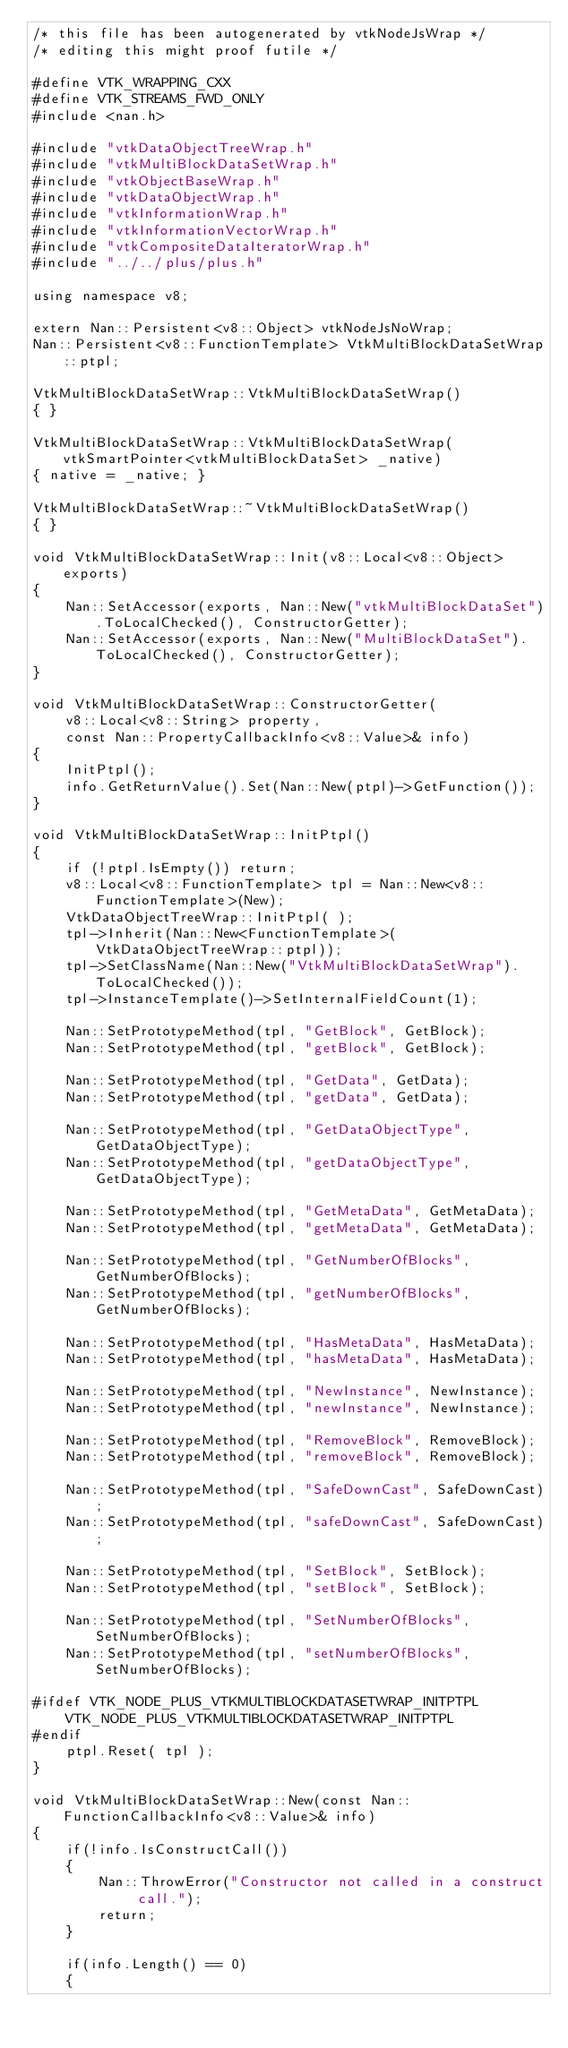Convert code to text. <code><loc_0><loc_0><loc_500><loc_500><_C++_>/* this file has been autogenerated by vtkNodeJsWrap */
/* editing this might proof futile */

#define VTK_WRAPPING_CXX
#define VTK_STREAMS_FWD_ONLY
#include <nan.h>

#include "vtkDataObjectTreeWrap.h"
#include "vtkMultiBlockDataSetWrap.h"
#include "vtkObjectBaseWrap.h"
#include "vtkDataObjectWrap.h"
#include "vtkInformationWrap.h"
#include "vtkInformationVectorWrap.h"
#include "vtkCompositeDataIteratorWrap.h"
#include "../../plus/plus.h"

using namespace v8;

extern Nan::Persistent<v8::Object> vtkNodeJsNoWrap;
Nan::Persistent<v8::FunctionTemplate> VtkMultiBlockDataSetWrap::ptpl;

VtkMultiBlockDataSetWrap::VtkMultiBlockDataSetWrap()
{ }

VtkMultiBlockDataSetWrap::VtkMultiBlockDataSetWrap(vtkSmartPointer<vtkMultiBlockDataSet> _native)
{ native = _native; }

VtkMultiBlockDataSetWrap::~VtkMultiBlockDataSetWrap()
{ }

void VtkMultiBlockDataSetWrap::Init(v8::Local<v8::Object> exports)
{
	Nan::SetAccessor(exports, Nan::New("vtkMultiBlockDataSet").ToLocalChecked(), ConstructorGetter);
	Nan::SetAccessor(exports, Nan::New("MultiBlockDataSet").ToLocalChecked(), ConstructorGetter);
}

void VtkMultiBlockDataSetWrap::ConstructorGetter(
	v8::Local<v8::String> property,
	const Nan::PropertyCallbackInfo<v8::Value>& info)
{
	InitPtpl();
	info.GetReturnValue().Set(Nan::New(ptpl)->GetFunction());
}

void VtkMultiBlockDataSetWrap::InitPtpl()
{
	if (!ptpl.IsEmpty()) return;
	v8::Local<v8::FunctionTemplate> tpl = Nan::New<v8::FunctionTemplate>(New);
	VtkDataObjectTreeWrap::InitPtpl( );
	tpl->Inherit(Nan::New<FunctionTemplate>(VtkDataObjectTreeWrap::ptpl));
	tpl->SetClassName(Nan::New("VtkMultiBlockDataSetWrap").ToLocalChecked());
	tpl->InstanceTemplate()->SetInternalFieldCount(1);

	Nan::SetPrototypeMethod(tpl, "GetBlock", GetBlock);
	Nan::SetPrototypeMethod(tpl, "getBlock", GetBlock);

	Nan::SetPrototypeMethod(tpl, "GetData", GetData);
	Nan::SetPrototypeMethod(tpl, "getData", GetData);

	Nan::SetPrototypeMethod(tpl, "GetDataObjectType", GetDataObjectType);
	Nan::SetPrototypeMethod(tpl, "getDataObjectType", GetDataObjectType);

	Nan::SetPrototypeMethod(tpl, "GetMetaData", GetMetaData);
	Nan::SetPrototypeMethod(tpl, "getMetaData", GetMetaData);

	Nan::SetPrototypeMethod(tpl, "GetNumberOfBlocks", GetNumberOfBlocks);
	Nan::SetPrototypeMethod(tpl, "getNumberOfBlocks", GetNumberOfBlocks);

	Nan::SetPrototypeMethod(tpl, "HasMetaData", HasMetaData);
	Nan::SetPrototypeMethod(tpl, "hasMetaData", HasMetaData);

	Nan::SetPrototypeMethod(tpl, "NewInstance", NewInstance);
	Nan::SetPrototypeMethod(tpl, "newInstance", NewInstance);

	Nan::SetPrototypeMethod(tpl, "RemoveBlock", RemoveBlock);
	Nan::SetPrototypeMethod(tpl, "removeBlock", RemoveBlock);

	Nan::SetPrototypeMethod(tpl, "SafeDownCast", SafeDownCast);
	Nan::SetPrototypeMethod(tpl, "safeDownCast", SafeDownCast);

	Nan::SetPrototypeMethod(tpl, "SetBlock", SetBlock);
	Nan::SetPrototypeMethod(tpl, "setBlock", SetBlock);

	Nan::SetPrototypeMethod(tpl, "SetNumberOfBlocks", SetNumberOfBlocks);
	Nan::SetPrototypeMethod(tpl, "setNumberOfBlocks", SetNumberOfBlocks);

#ifdef VTK_NODE_PLUS_VTKMULTIBLOCKDATASETWRAP_INITPTPL
	VTK_NODE_PLUS_VTKMULTIBLOCKDATASETWRAP_INITPTPL
#endif
	ptpl.Reset( tpl );
}

void VtkMultiBlockDataSetWrap::New(const Nan::FunctionCallbackInfo<v8::Value>& info)
{
	if(!info.IsConstructCall())
	{
		Nan::ThrowError("Constructor not called in a construct call.");
		return;
	}

	if(info.Length() == 0)
	{</code> 